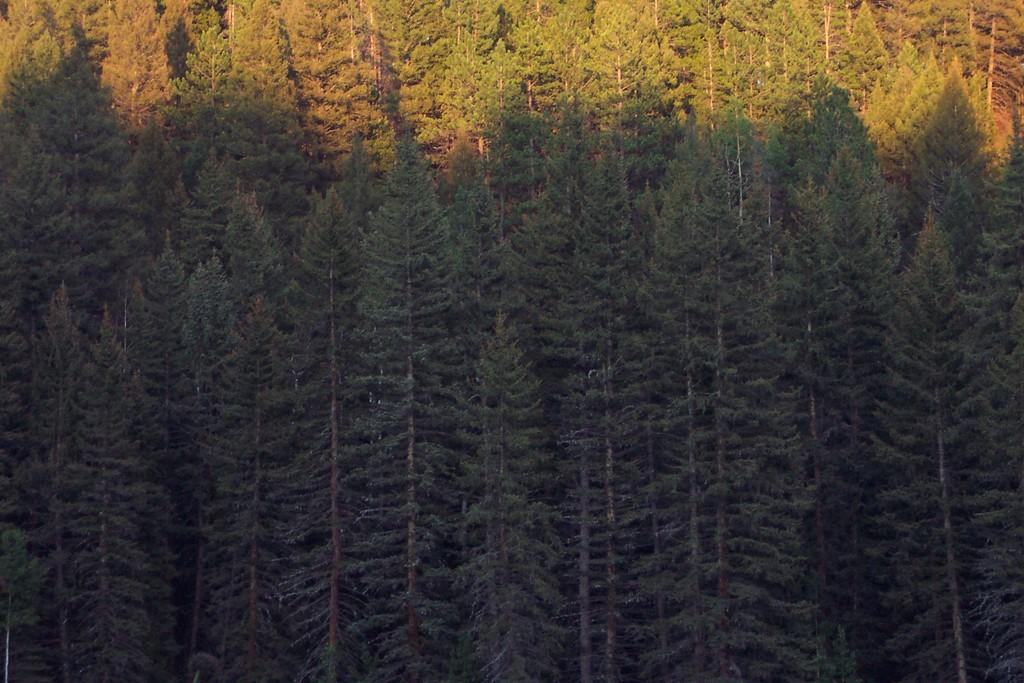What type of vegetation can be seen in the image? There are trees in the image. Can you hear the trees in the image using your ear? The image is a visual representation and does not contain audible elements, so it is not possible to hear the trees using an ear. 